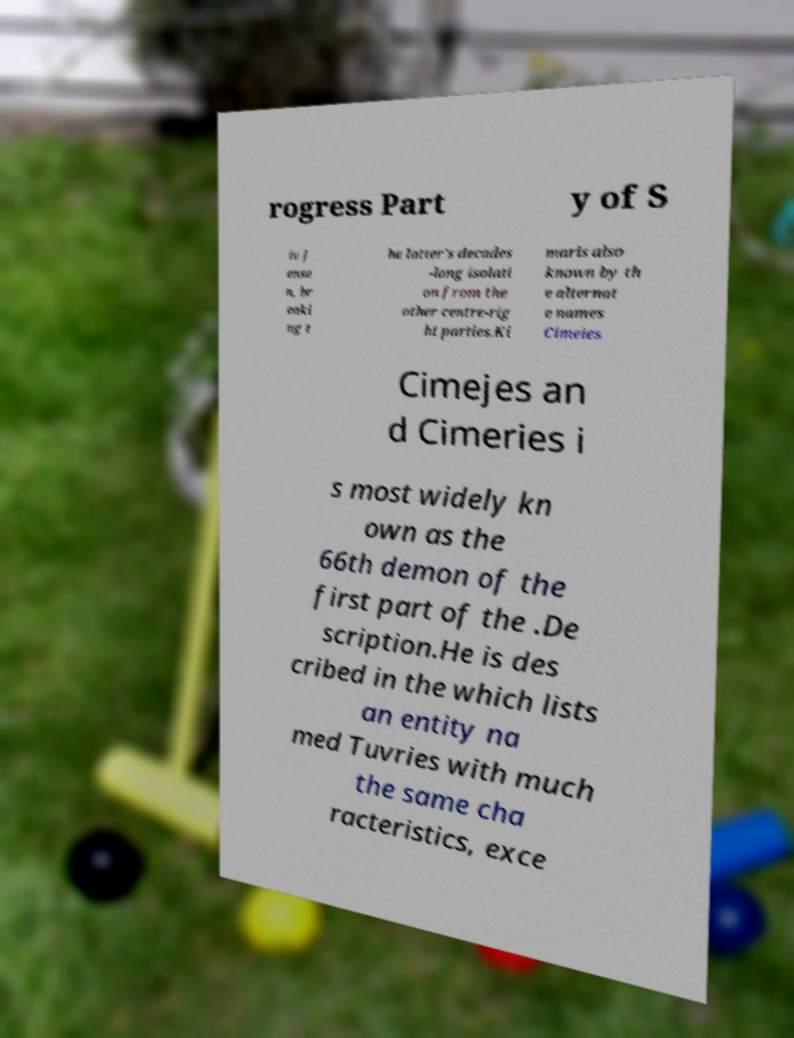Can you accurately transcribe the text from the provided image for me? rogress Part y of S iv J ense n, br eaki ng t he latter's decades -long isolati on from the other centre-rig ht parties.Ki maris also known by th e alternat e names Cimeies Cimejes an d Cimeries i s most widely kn own as the 66th demon of the first part of the .De scription.He is des cribed in the which lists an entity na med Tuvries with much the same cha racteristics, exce 